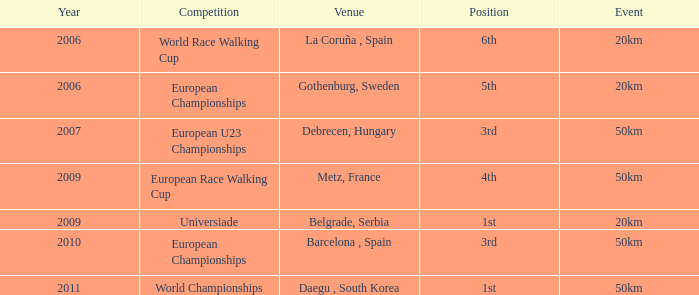Which event holds the 5th place in the european championships competition? 20km. 